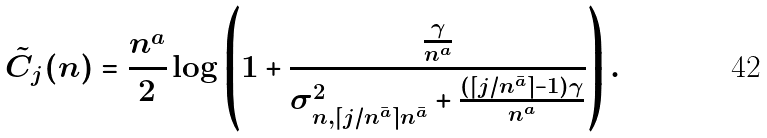<formula> <loc_0><loc_0><loc_500><loc_500>\tilde { C } _ { j } ( n ) = \frac { n ^ { a } } { 2 } \log \left ( 1 + \frac { \frac { \gamma } { n ^ { a } } } { \sigma _ { n , \lceil j / n ^ { \bar { a } } \rceil n ^ { \bar { a } } } ^ { 2 } + \frac { ( \lceil j / n ^ { \bar { a } } \rceil - 1 ) \gamma } { n ^ { a } } } \right ) .</formula> 